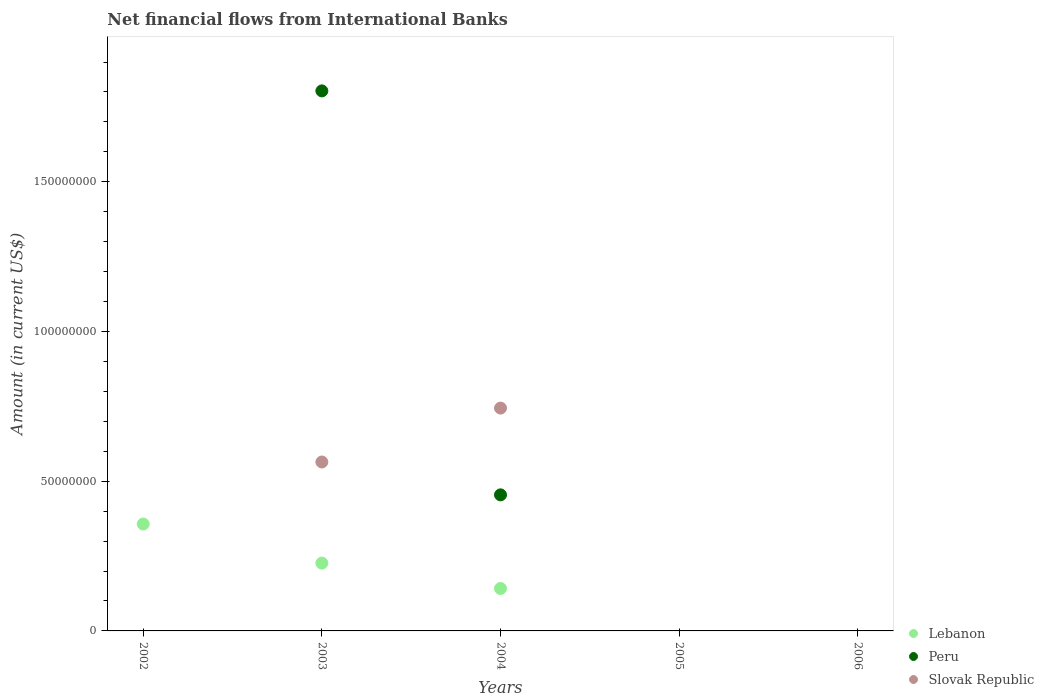What is the net financial aid flows in Lebanon in 2004?
Provide a short and direct response. 1.42e+07. Across all years, what is the maximum net financial aid flows in Peru?
Offer a very short reply. 1.80e+08. What is the total net financial aid flows in Slovak Republic in the graph?
Offer a very short reply. 1.31e+08. What is the difference between the net financial aid flows in Peru in 2004 and the net financial aid flows in Slovak Republic in 2002?
Offer a terse response. 4.54e+07. What is the average net financial aid flows in Lebanon per year?
Your answer should be very brief. 1.45e+07. In the year 2004, what is the difference between the net financial aid flows in Lebanon and net financial aid flows in Slovak Republic?
Keep it short and to the point. -6.03e+07. What is the ratio of the net financial aid flows in Lebanon in 2002 to that in 2003?
Your response must be concise. 1.58. Is the difference between the net financial aid flows in Lebanon in 2003 and 2004 greater than the difference between the net financial aid flows in Slovak Republic in 2003 and 2004?
Your response must be concise. Yes. What is the difference between the highest and the second highest net financial aid flows in Lebanon?
Your answer should be compact. 1.30e+07. What is the difference between the highest and the lowest net financial aid flows in Lebanon?
Make the answer very short. 3.57e+07. Is the sum of the net financial aid flows in Peru in 2003 and 2004 greater than the maximum net financial aid flows in Lebanon across all years?
Your answer should be compact. Yes. Does the net financial aid flows in Lebanon monotonically increase over the years?
Give a very brief answer. No. Is the net financial aid flows in Peru strictly greater than the net financial aid flows in Slovak Republic over the years?
Offer a very short reply. No. How many dotlines are there?
Provide a short and direct response. 3. How many years are there in the graph?
Your answer should be compact. 5. Does the graph contain any zero values?
Give a very brief answer. Yes. Where does the legend appear in the graph?
Make the answer very short. Bottom right. What is the title of the graph?
Keep it short and to the point. Net financial flows from International Banks. What is the label or title of the X-axis?
Keep it short and to the point. Years. What is the Amount (in current US$) in Lebanon in 2002?
Offer a very short reply. 3.57e+07. What is the Amount (in current US$) in Peru in 2002?
Give a very brief answer. 0. What is the Amount (in current US$) in Lebanon in 2003?
Offer a very short reply. 2.27e+07. What is the Amount (in current US$) in Peru in 2003?
Provide a succinct answer. 1.80e+08. What is the Amount (in current US$) of Slovak Republic in 2003?
Offer a terse response. 5.64e+07. What is the Amount (in current US$) of Lebanon in 2004?
Ensure brevity in your answer.  1.42e+07. What is the Amount (in current US$) in Peru in 2004?
Your answer should be compact. 4.54e+07. What is the Amount (in current US$) in Slovak Republic in 2004?
Provide a succinct answer. 7.44e+07. What is the Amount (in current US$) in Lebanon in 2005?
Provide a succinct answer. 0. What is the Amount (in current US$) in Lebanon in 2006?
Keep it short and to the point. 0. What is the Amount (in current US$) of Slovak Republic in 2006?
Ensure brevity in your answer.  0. Across all years, what is the maximum Amount (in current US$) of Lebanon?
Make the answer very short. 3.57e+07. Across all years, what is the maximum Amount (in current US$) in Peru?
Provide a succinct answer. 1.80e+08. Across all years, what is the maximum Amount (in current US$) in Slovak Republic?
Your response must be concise. 7.44e+07. Across all years, what is the minimum Amount (in current US$) of Lebanon?
Provide a succinct answer. 0. What is the total Amount (in current US$) of Lebanon in the graph?
Give a very brief answer. 7.25e+07. What is the total Amount (in current US$) in Peru in the graph?
Offer a very short reply. 2.26e+08. What is the total Amount (in current US$) of Slovak Republic in the graph?
Keep it short and to the point. 1.31e+08. What is the difference between the Amount (in current US$) of Lebanon in 2002 and that in 2003?
Ensure brevity in your answer.  1.30e+07. What is the difference between the Amount (in current US$) of Lebanon in 2002 and that in 2004?
Your answer should be compact. 2.15e+07. What is the difference between the Amount (in current US$) in Lebanon in 2003 and that in 2004?
Offer a terse response. 8.48e+06. What is the difference between the Amount (in current US$) in Peru in 2003 and that in 2004?
Your response must be concise. 1.35e+08. What is the difference between the Amount (in current US$) in Slovak Republic in 2003 and that in 2004?
Provide a succinct answer. -1.80e+07. What is the difference between the Amount (in current US$) of Lebanon in 2002 and the Amount (in current US$) of Peru in 2003?
Ensure brevity in your answer.  -1.45e+08. What is the difference between the Amount (in current US$) of Lebanon in 2002 and the Amount (in current US$) of Slovak Republic in 2003?
Provide a short and direct response. -2.07e+07. What is the difference between the Amount (in current US$) of Lebanon in 2002 and the Amount (in current US$) of Peru in 2004?
Ensure brevity in your answer.  -9.74e+06. What is the difference between the Amount (in current US$) of Lebanon in 2002 and the Amount (in current US$) of Slovak Republic in 2004?
Your answer should be compact. -3.87e+07. What is the difference between the Amount (in current US$) of Lebanon in 2003 and the Amount (in current US$) of Peru in 2004?
Give a very brief answer. -2.28e+07. What is the difference between the Amount (in current US$) of Lebanon in 2003 and the Amount (in current US$) of Slovak Republic in 2004?
Offer a very short reply. -5.18e+07. What is the difference between the Amount (in current US$) of Peru in 2003 and the Amount (in current US$) of Slovak Republic in 2004?
Make the answer very short. 1.06e+08. What is the average Amount (in current US$) in Lebanon per year?
Offer a terse response. 1.45e+07. What is the average Amount (in current US$) of Peru per year?
Your response must be concise. 4.52e+07. What is the average Amount (in current US$) in Slovak Republic per year?
Offer a terse response. 2.62e+07. In the year 2003, what is the difference between the Amount (in current US$) of Lebanon and Amount (in current US$) of Peru?
Provide a short and direct response. -1.58e+08. In the year 2003, what is the difference between the Amount (in current US$) in Lebanon and Amount (in current US$) in Slovak Republic?
Offer a terse response. -3.38e+07. In the year 2003, what is the difference between the Amount (in current US$) of Peru and Amount (in current US$) of Slovak Republic?
Keep it short and to the point. 1.24e+08. In the year 2004, what is the difference between the Amount (in current US$) of Lebanon and Amount (in current US$) of Peru?
Keep it short and to the point. -3.13e+07. In the year 2004, what is the difference between the Amount (in current US$) in Lebanon and Amount (in current US$) in Slovak Republic?
Make the answer very short. -6.03e+07. In the year 2004, what is the difference between the Amount (in current US$) of Peru and Amount (in current US$) of Slovak Republic?
Your answer should be compact. -2.90e+07. What is the ratio of the Amount (in current US$) in Lebanon in 2002 to that in 2003?
Make the answer very short. 1.58. What is the ratio of the Amount (in current US$) in Lebanon in 2002 to that in 2004?
Provide a succinct answer. 2.52. What is the ratio of the Amount (in current US$) in Lebanon in 2003 to that in 2004?
Ensure brevity in your answer.  1.6. What is the ratio of the Amount (in current US$) of Peru in 2003 to that in 2004?
Provide a short and direct response. 3.97. What is the ratio of the Amount (in current US$) in Slovak Republic in 2003 to that in 2004?
Keep it short and to the point. 0.76. What is the difference between the highest and the second highest Amount (in current US$) of Lebanon?
Ensure brevity in your answer.  1.30e+07. What is the difference between the highest and the lowest Amount (in current US$) of Lebanon?
Your response must be concise. 3.57e+07. What is the difference between the highest and the lowest Amount (in current US$) in Peru?
Your answer should be compact. 1.80e+08. What is the difference between the highest and the lowest Amount (in current US$) in Slovak Republic?
Offer a very short reply. 7.44e+07. 